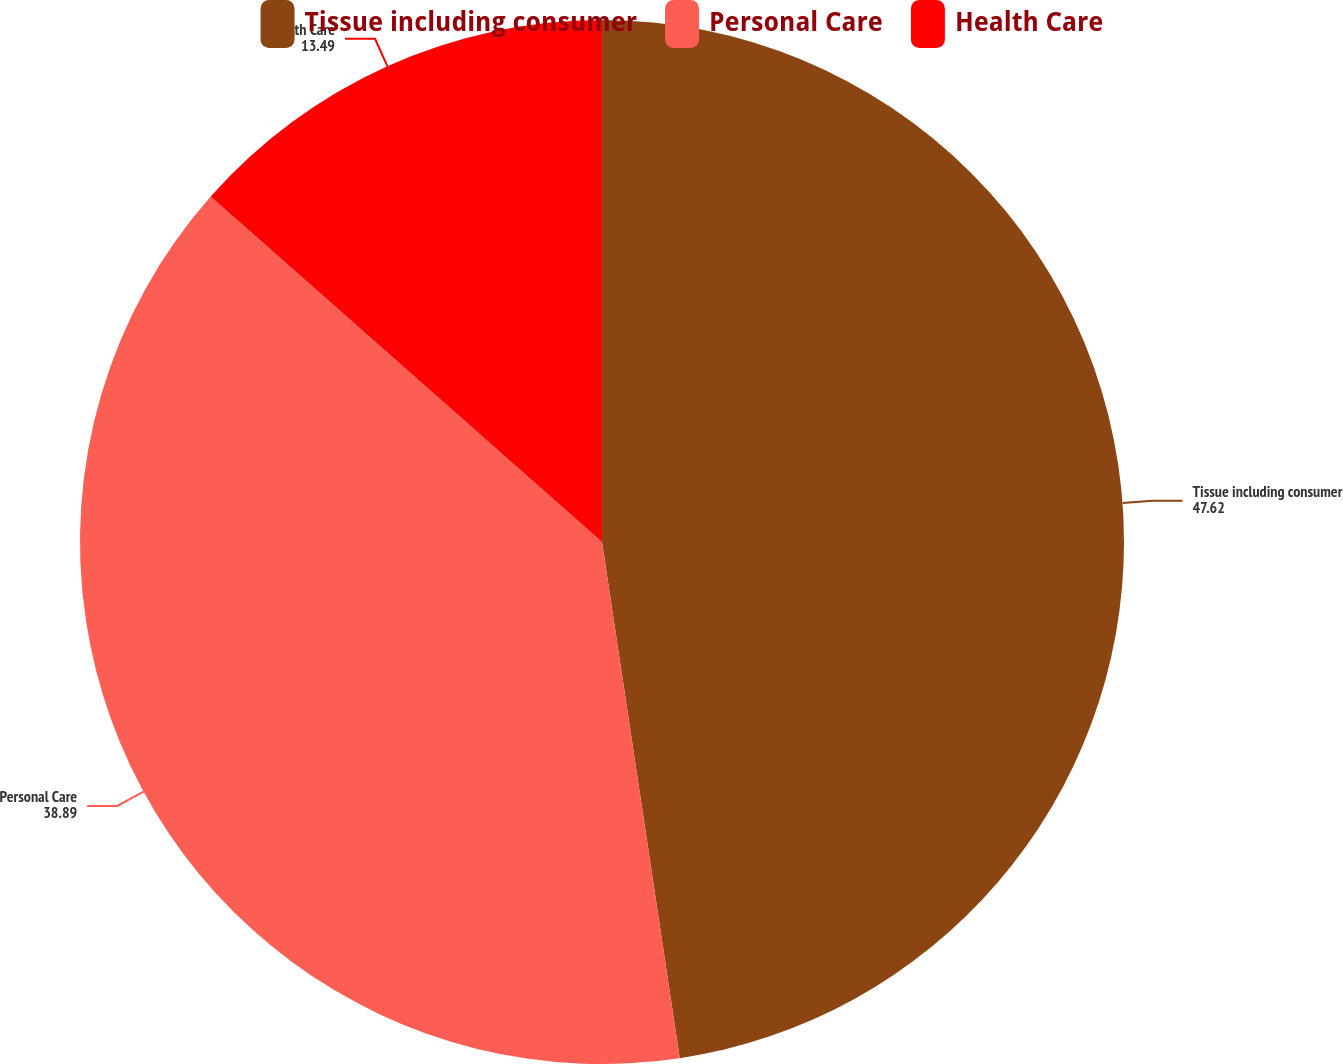Convert chart. <chart><loc_0><loc_0><loc_500><loc_500><pie_chart><fcel>Tissue including consumer<fcel>Personal Care<fcel>Health Care<nl><fcel>47.62%<fcel>38.89%<fcel>13.49%<nl></chart> 